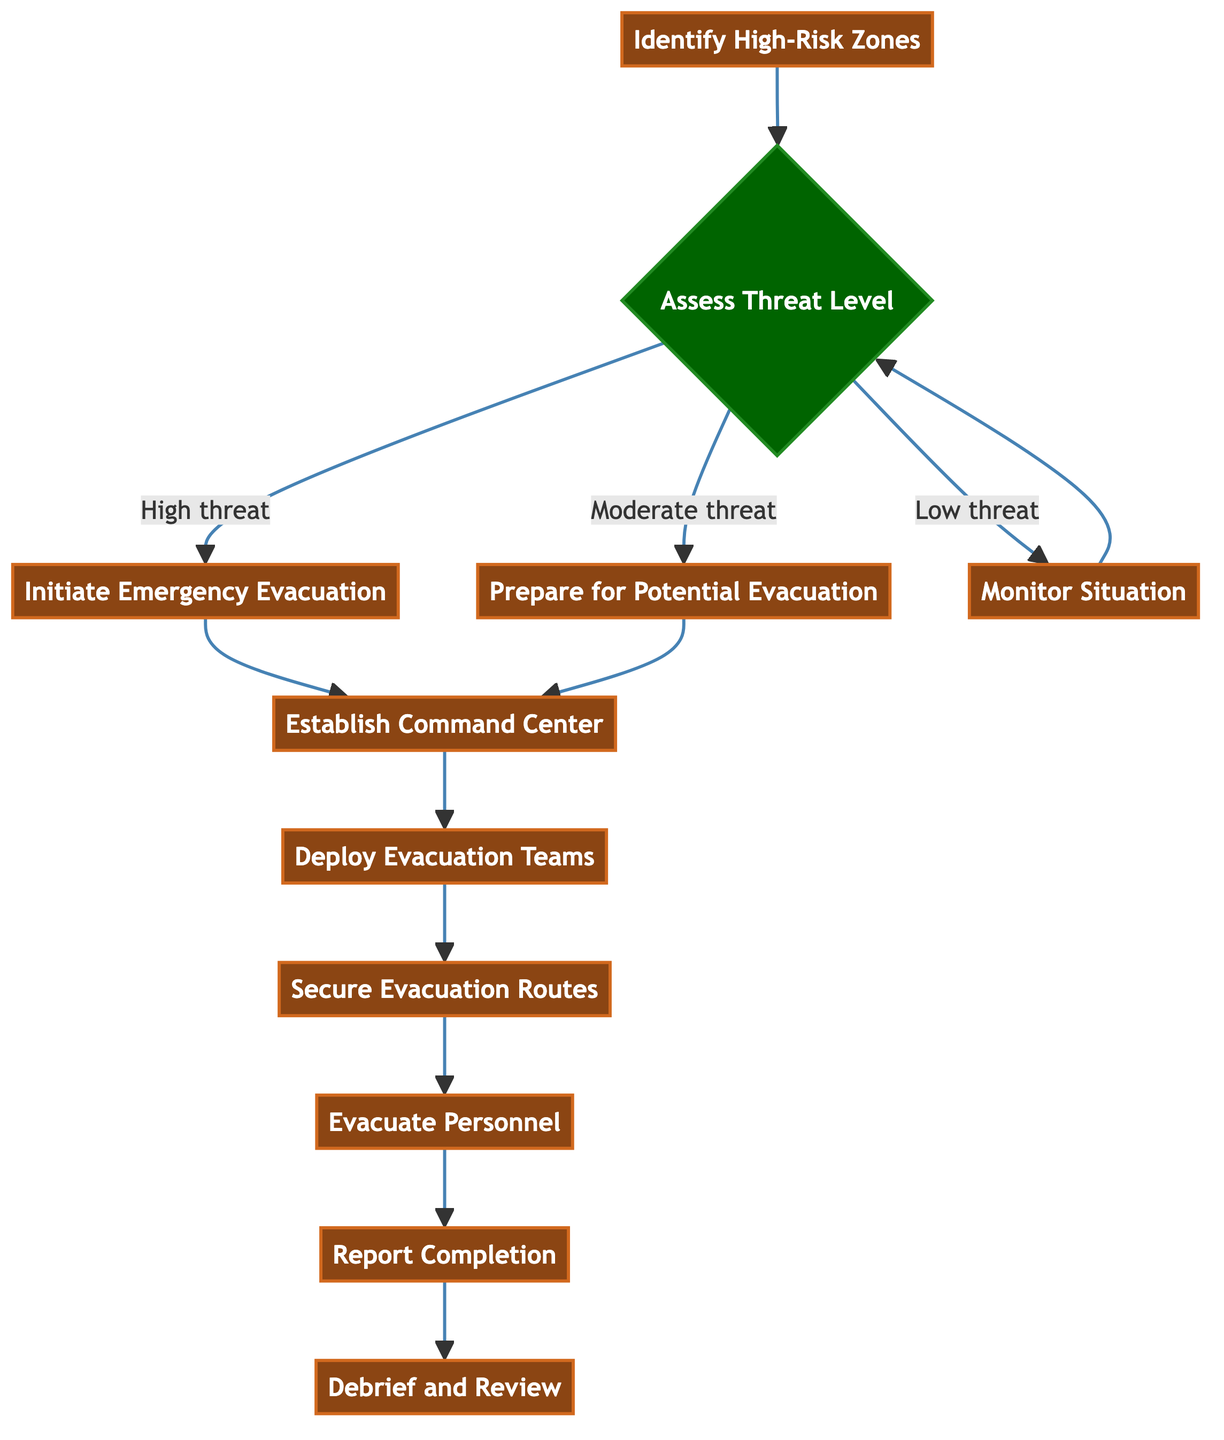What is the first step in the evacuation procedure? The first step is "Identify High-Risk Zones," which is the initial process in the chart that gathers intelligence about conflict areas needing evacuation.
Answer: Identify High-Risk Zones How many decision points are in the diagram? The diagram contains one decision point, which is "Assess Threat Level," where different paths are taken based on the threat assessment.
Answer: 1 What follows "Prepare for Potential Evacuation"? After "Prepare for Potential Evacuation," the next step is "Establish Command Center," which is where coordination for the evacuation occurs.
Answer: Establish Command Center What action is taken if the threat level is low? If the threat level is low, the action is to "Monitor Situation," which involves keeping an eye on the situation while being prepared to escalate if necessary.
Answer: Monitor Situation What is the last step of the evacuation procedure? The last step in the evacuation procedure is "Debrief and Review," where all teams conduct a debrief to review their performance during the operation.
Answer: Debrief and Review What happens after initiating emergency evacuation? After initiating emergency evacuation, the next step is to "Establish Command Center," which is critical for organizing and managing the evacuation effort.
Answer: Establish Command Center Which node leads to securing evacuation routes? The node that leads to securing evacuation routes is "Deploy Evacuation Teams," as evacuation teams must be dispatched before ensuring routes are clear.
Answer: Deploy Evacuation Teams What describes the relationship between "Assess Threat Level" and "Initiate Emergency Evacuation"? "Assess Threat Level" is a decision node that can lead directly to "Initiate Emergency Evacuation" if the assessed threat is high, indicating a direct relationship based on a condition.
Answer: Direct relationship based on condition How many total processes are in the diagram? The diagram contains a total of eight processes, which include several steps involved in the evacuation procedure.
Answer: 8 